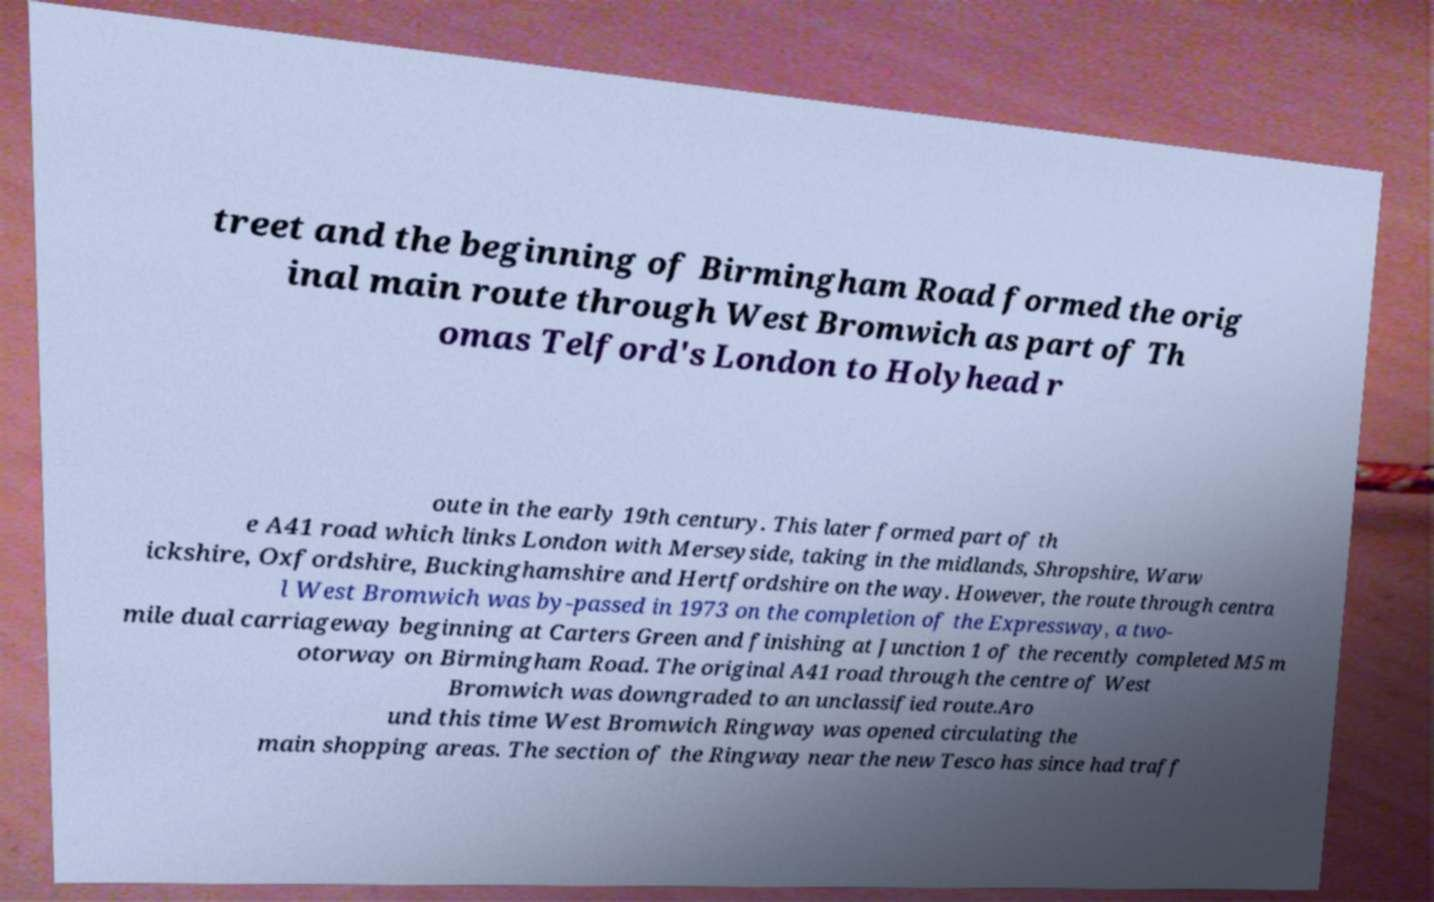Could you extract and type out the text from this image? treet and the beginning of Birmingham Road formed the orig inal main route through West Bromwich as part of Th omas Telford's London to Holyhead r oute in the early 19th century. This later formed part of th e A41 road which links London with Merseyside, taking in the midlands, Shropshire, Warw ickshire, Oxfordshire, Buckinghamshire and Hertfordshire on the way. However, the route through centra l West Bromwich was by-passed in 1973 on the completion of the Expressway, a two- mile dual carriageway beginning at Carters Green and finishing at Junction 1 of the recently completed M5 m otorway on Birmingham Road. The original A41 road through the centre of West Bromwich was downgraded to an unclassified route.Aro und this time West Bromwich Ringway was opened circulating the main shopping areas. The section of the Ringway near the new Tesco has since had traff 